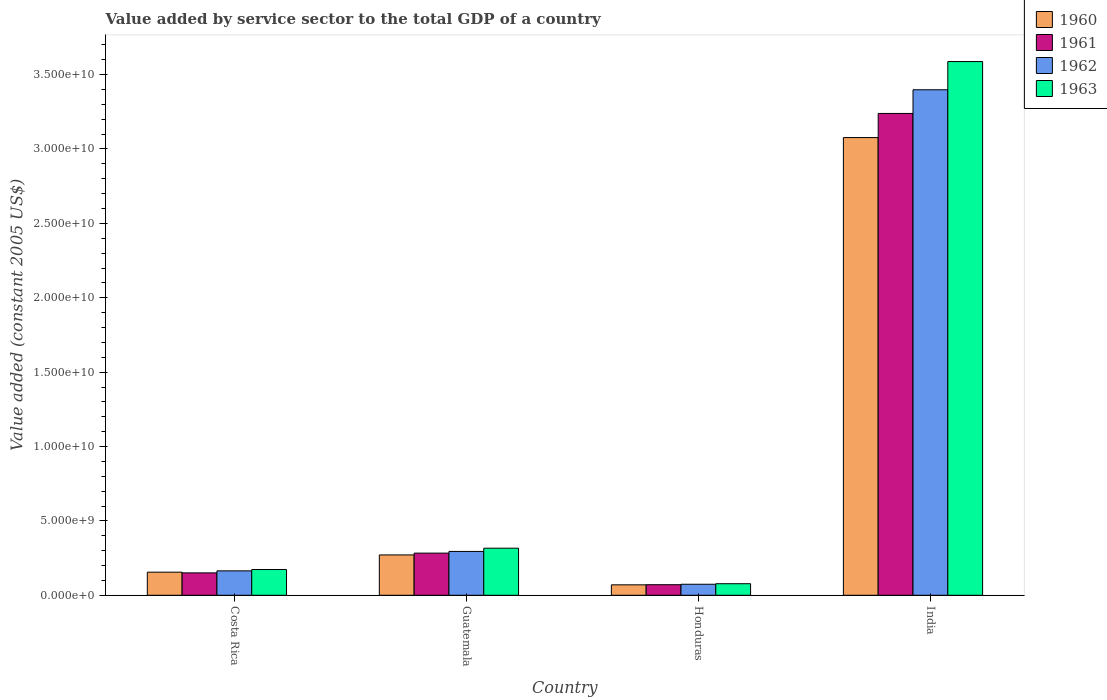How many different coloured bars are there?
Your answer should be compact. 4. Are the number of bars per tick equal to the number of legend labels?
Provide a succinct answer. Yes. What is the label of the 3rd group of bars from the left?
Offer a very short reply. Honduras. In how many cases, is the number of bars for a given country not equal to the number of legend labels?
Offer a very short reply. 0. What is the value added by service sector in 1963 in India?
Keep it short and to the point. 3.59e+1. Across all countries, what is the maximum value added by service sector in 1963?
Provide a short and direct response. 3.59e+1. Across all countries, what is the minimum value added by service sector in 1961?
Keep it short and to the point. 7.12e+08. In which country was the value added by service sector in 1961 minimum?
Offer a terse response. Honduras. What is the total value added by service sector in 1960 in the graph?
Keep it short and to the point. 3.57e+1. What is the difference between the value added by service sector in 1961 in Guatemala and that in Honduras?
Your answer should be compact. 2.12e+09. What is the difference between the value added by service sector in 1963 in Guatemala and the value added by service sector in 1962 in India?
Give a very brief answer. -3.08e+1. What is the average value added by service sector in 1960 per country?
Your answer should be compact. 8.93e+09. What is the difference between the value added by service sector of/in 1960 and value added by service sector of/in 1963 in Guatemala?
Offer a very short reply. -4.53e+08. What is the ratio of the value added by service sector in 1961 in Costa Rica to that in Honduras?
Make the answer very short. 2.12. What is the difference between the highest and the second highest value added by service sector in 1961?
Your response must be concise. 2.96e+1. What is the difference between the highest and the lowest value added by service sector in 1961?
Give a very brief answer. 3.17e+1. Is it the case that in every country, the sum of the value added by service sector in 1960 and value added by service sector in 1962 is greater than the sum of value added by service sector in 1963 and value added by service sector in 1961?
Make the answer very short. No. Are all the bars in the graph horizontal?
Keep it short and to the point. No. What is the difference between two consecutive major ticks on the Y-axis?
Keep it short and to the point. 5.00e+09. Where does the legend appear in the graph?
Your answer should be compact. Top right. What is the title of the graph?
Offer a very short reply. Value added by service sector to the total GDP of a country. Does "1970" appear as one of the legend labels in the graph?
Your response must be concise. No. What is the label or title of the X-axis?
Give a very brief answer. Country. What is the label or title of the Y-axis?
Ensure brevity in your answer.  Value added (constant 2005 US$). What is the Value added (constant 2005 US$) of 1960 in Costa Rica?
Give a very brief answer. 1.55e+09. What is the Value added (constant 2005 US$) of 1961 in Costa Rica?
Offer a terse response. 1.51e+09. What is the Value added (constant 2005 US$) of 1962 in Costa Rica?
Keep it short and to the point. 1.64e+09. What is the Value added (constant 2005 US$) in 1963 in Costa Rica?
Your answer should be very brief. 1.73e+09. What is the Value added (constant 2005 US$) in 1960 in Guatemala?
Ensure brevity in your answer.  2.71e+09. What is the Value added (constant 2005 US$) in 1961 in Guatemala?
Provide a short and direct response. 2.83e+09. What is the Value added (constant 2005 US$) of 1962 in Guatemala?
Offer a terse response. 2.95e+09. What is the Value added (constant 2005 US$) of 1963 in Guatemala?
Offer a very short reply. 3.16e+09. What is the Value added (constant 2005 US$) in 1960 in Honduras?
Provide a short and direct response. 7.01e+08. What is the Value added (constant 2005 US$) in 1961 in Honduras?
Your answer should be very brief. 7.12e+08. What is the Value added (constant 2005 US$) in 1962 in Honduras?
Your answer should be compact. 7.41e+08. What is the Value added (constant 2005 US$) in 1963 in Honduras?
Your response must be concise. 7.78e+08. What is the Value added (constant 2005 US$) of 1960 in India?
Give a very brief answer. 3.08e+1. What is the Value added (constant 2005 US$) in 1961 in India?
Your answer should be compact. 3.24e+1. What is the Value added (constant 2005 US$) in 1962 in India?
Give a very brief answer. 3.40e+1. What is the Value added (constant 2005 US$) of 1963 in India?
Ensure brevity in your answer.  3.59e+1. Across all countries, what is the maximum Value added (constant 2005 US$) in 1960?
Make the answer very short. 3.08e+1. Across all countries, what is the maximum Value added (constant 2005 US$) of 1961?
Your response must be concise. 3.24e+1. Across all countries, what is the maximum Value added (constant 2005 US$) of 1962?
Your answer should be very brief. 3.40e+1. Across all countries, what is the maximum Value added (constant 2005 US$) of 1963?
Ensure brevity in your answer.  3.59e+1. Across all countries, what is the minimum Value added (constant 2005 US$) of 1960?
Your answer should be very brief. 7.01e+08. Across all countries, what is the minimum Value added (constant 2005 US$) in 1961?
Provide a short and direct response. 7.12e+08. Across all countries, what is the minimum Value added (constant 2005 US$) of 1962?
Offer a terse response. 7.41e+08. Across all countries, what is the minimum Value added (constant 2005 US$) of 1963?
Offer a very short reply. 7.78e+08. What is the total Value added (constant 2005 US$) of 1960 in the graph?
Make the answer very short. 3.57e+1. What is the total Value added (constant 2005 US$) of 1961 in the graph?
Your answer should be compact. 3.74e+1. What is the total Value added (constant 2005 US$) in 1962 in the graph?
Make the answer very short. 3.93e+1. What is the total Value added (constant 2005 US$) of 1963 in the graph?
Keep it short and to the point. 4.16e+1. What is the difference between the Value added (constant 2005 US$) in 1960 in Costa Rica and that in Guatemala?
Your answer should be compact. -1.16e+09. What is the difference between the Value added (constant 2005 US$) in 1961 in Costa Rica and that in Guatemala?
Offer a very short reply. -1.33e+09. What is the difference between the Value added (constant 2005 US$) of 1962 in Costa Rica and that in Guatemala?
Give a very brief answer. -1.31e+09. What is the difference between the Value added (constant 2005 US$) of 1963 in Costa Rica and that in Guatemala?
Your answer should be compact. -1.43e+09. What is the difference between the Value added (constant 2005 US$) in 1960 in Costa Rica and that in Honduras?
Provide a succinct answer. 8.51e+08. What is the difference between the Value added (constant 2005 US$) of 1961 in Costa Rica and that in Honduras?
Your answer should be very brief. 7.94e+08. What is the difference between the Value added (constant 2005 US$) of 1962 in Costa Rica and that in Honduras?
Your answer should be very brief. 9.01e+08. What is the difference between the Value added (constant 2005 US$) of 1963 in Costa Rica and that in Honduras?
Make the answer very short. 9.53e+08. What is the difference between the Value added (constant 2005 US$) of 1960 in Costa Rica and that in India?
Offer a terse response. -2.92e+1. What is the difference between the Value added (constant 2005 US$) in 1961 in Costa Rica and that in India?
Your response must be concise. -3.09e+1. What is the difference between the Value added (constant 2005 US$) of 1962 in Costa Rica and that in India?
Give a very brief answer. -3.23e+1. What is the difference between the Value added (constant 2005 US$) of 1963 in Costa Rica and that in India?
Make the answer very short. -3.41e+1. What is the difference between the Value added (constant 2005 US$) in 1960 in Guatemala and that in Honduras?
Give a very brief answer. 2.01e+09. What is the difference between the Value added (constant 2005 US$) in 1961 in Guatemala and that in Honduras?
Give a very brief answer. 2.12e+09. What is the difference between the Value added (constant 2005 US$) in 1962 in Guatemala and that in Honduras?
Offer a terse response. 2.21e+09. What is the difference between the Value added (constant 2005 US$) in 1963 in Guatemala and that in Honduras?
Offer a very short reply. 2.39e+09. What is the difference between the Value added (constant 2005 US$) in 1960 in Guatemala and that in India?
Provide a short and direct response. -2.81e+1. What is the difference between the Value added (constant 2005 US$) in 1961 in Guatemala and that in India?
Provide a succinct answer. -2.96e+1. What is the difference between the Value added (constant 2005 US$) of 1962 in Guatemala and that in India?
Ensure brevity in your answer.  -3.10e+1. What is the difference between the Value added (constant 2005 US$) of 1963 in Guatemala and that in India?
Keep it short and to the point. -3.27e+1. What is the difference between the Value added (constant 2005 US$) in 1960 in Honduras and that in India?
Provide a succinct answer. -3.01e+1. What is the difference between the Value added (constant 2005 US$) of 1961 in Honduras and that in India?
Provide a succinct answer. -3.17e+1. What is the difference between the Value added (constant 2005 US$) in 1962 in Honduras and that in India?
Your answer should be compact. -3.32e+1. What is the difference between the Value added (constant 2005 US$) in 1963 in Honduras and that in India?
Your answer should be compact. -3.51e+1. What is the difference between the Value added (constant 2005 US$) of 1960 in Costa Rica and the Value added (constant 2005 US$) of 1961 in Guatemala?
Give a very brief answer. -1.28e+09. What is the difference between the Value added (constant 2005 US$) of 1960 in Costa Rica and the Value added (constant 2005 US$) of 1962 in Guatemala?
Provide a short and direct response. -1.39e+09. What is the difference between the Value added (constant 2005 US$) in 1960 in Costa Rica and the Value added (constant 2005 US$) in 1963 in Guatemala?
Your answer should be compact. -1.61e+09. What is the difference between the Value added (constant 2005 US$) in 1961 in Costa Rica and the Value added (constant 2005 US$) in 1962 in Guatemala?
Your response must be concise. -1.44e+09. What is the difference between the Value added (constant 2005 US$) in 1961 in Costa Rica and the Value added (constant 2005 US$) in 1963 in Guatemala?
Ensure brevity in your answer.  -1.66e+09. What is the difference between the Value added (constant 2005 US$) of 1962 in Costa Rica and the Value added (constant 2005 US$) of 1963 in Guatemala?
Provide a succinct answer. -1.52e+09. What is the difference between the Value added (constant 2005 US$) of 1960 in Costa Rica and the Value added (constant 2005 US$) of 1961 in Honduras?
Your answer should be very brief. 8.41e+08. What is the difference between the Value added (constant 2005 US$) of 1960 in Costa Rica and the Value added (constant 2005 US$) of 1962 in Honduras?
Provide a short and direct response. 8.12e+08. What is the difference between the Value added (constant 2005 US$) in 1960 in Costa Rica and the Value added (constant 2005 US$) in 1963 in Honduras?
Make the answer very short. 7.75e+08. What is the difference between the Value added (constant 2005 US$) in 1961 in Costa Rica and the Value added (constant 2005 US$) in 1962 in Honduras?
Your answer should be compact. 7.65e+08. What is the difference between the Value added (constant 2005 US$) of 1961 in Costa Rica and the Value added (constant 2005 US$) of 1963 in Honduras?
Offer a very short reply. 7.28e+08. What is the difference between the Value added (constant 2005 US$) in 1962 in Costa Rica and the Value added (constant 2005 US$) in 1963 in Honduras?
Make the answer very short. 8.63e+08. What is the difference between the Value added (constant 2005 US$) in 1960 in Costa Rica and the Value added (constant 2005 US$) in 1961 in India?
Your answer should be compact. -3.08e+1. What is the difference between the Value added (constant 2005 US$) in 1960 in Costa Rica and the Value added (constant 2005 US$) in 1962 in India?
Your answer should be compact. -3.24e+1. What is the difference between the Value added (constant 2005 US$) in 1960 in Costa Rica and the Value added (constant 2005 US$) in 1963 in India?
Give a very brief answer. -3.43e+1. What is the difference between the Value added (constant 2005 US$) of 1961 in Costa Rica and the Value added (constant 2005 US$) of 1962 in India?
Offer a terse response. -3.25e+1. What is the difference between the Value added (constant 2005 US$) in 1961 in Costa Rica and the Value added (constant 2005 US$) in 1963 in India?
Keep it short and to the point. -3.44e+1. What is the difference between the Value added (constant 2005 US$) of 1962 in Costa Rica and the Value added (constant 2005 US$) of 1963 in India?
Give a very brief answer. -3.42e+1. What is the difference between the Value added (constant 2005 US$) in 1960 in Guatemala and the Value added (constant 2005 US$) in 1961 in Honduras?
Provide a succinct answer. 2.00e+09. What is the difference between the Value added (constant 2005 US$) in 1960 in Guatemala and the Value added (constant 2005 US$) in 1962 in Honduras?
Your answer should be very brief. 1.97e+09. What is the difference between the Value added (constant 2005 US$) in 1960 in Guatemala and the Value added (constant 2005 US$) in 1963 in Honduras?
Your answer should be very brief. 1.93e+09. What is the difference between the Value added (constant 2005 US$) in 1961 in Guatemala and the Value added (constant 2005 US$) in 1962 in Honduras?
Your answer should be compact. 2.09e+09. What is the difference between the Value added (constant 2005 US$) of 1961 in Guatemala and the Value added (constant 2005 US$) of 1963 in Honduras?
Your answer should be very brief. 2.06e+09. What is the difference between the Value added (constant 2005 US$) of 1962 in Guatemala and the Value added (constant 2005 US$) of 1963 in Honduras?
Offer a terse response. 2.17e+09. What is the difference between the Value added (constant 2005 US$) of 1960 in Guatemala and the Value added (constant 2005 US$) of 1961 in India?
Offer a very short reply. -2.97e+1. What is the difference between the Value added (constant 2005 US$) of 1960 in Guatemala and the Value added (constant 2005 US$) of 1962 in India?
Keep it short and to the point. -3.13e+1. What is the difference between the Value added (constant 2005 US$) of 1960 in Guatemala and the Value added (constant 2005 US$) of 1963 in India?
Offer a terse response. -3.32e+1. What is the difference between the Value added (constant 2005 US$) in 1961 in Guatemala and the Value added (constant 2005 US$) in 1962 in India?
Your answer should be very brief. -3.11e+1. What is the difference between the Value added (constant 2005 US$) of 1961 in Guatemala and the Value added (constant 2005 US$) of 1963 in India?
Provide a short and direct response. -3.30e+1. What is the difference between the Value added (constant 2005 US$) of 1962 in Guatemala and the Value added (constant 2005 US$) of 1963 in India?
Your answer should be compact. -3.29e+1. What is the difference between the Value added (constant 2005 US$) in 1960 in Honduras and the Value added (constant 2005 US$) in 1961 in India?
Keep it short and to the point. -3.17e+1. What is the difference between the Value added (constant 2005 US$) in 1960 in Honduras and the Value added (constant 2005 US$) in 1962 in India?
Your answer should be very brief. -3.33e+1. What is the difference between the Value added (constant 2005 US$) of 1960 in Honduras and the Value added (constant 2005 US$) of 1963 in India?
Provide a succinct answer. -3.52e+1. What is the difference between the Value added (constant 2005 US$) of 1961 in Honduras and the Value added (constant 2005 US$) of 1962 in India?
Your answer should be very brief. -3.33e+1. What is the difference between the Value added (constant 2005 US$) in 1961 in Honduras and the Value added (constant 2005 US$) in 1963 in India?
Give a very brief answer. -3.52e+1. What is the difference between the Value added (constant 2005 US$) in 1962 in Honduras and the Value added (constant 2005 US$) in 1963 in India?
Ensure brevity in your answer.  -3.51e+1. What is the average Value added (constant 2005 US$) in 1960 per country?
Offer a very short reply. 8.93e+09. What is the average Value added (constant 2005 US$) in 1961 per country?
Your answer should be compact. 9.36e+09. What is the average Value added (constant 2005 US$) in 1962 per country?
Provide a short and direct response. 9.83e+09. What is the average Value added (constant 2005 US$) in 1963 per country?
Provide a short and direct response. 1.04e+1. What is the difference between the Value added (constant 2005 US$) in 1960 and Value added (constant 2005 US$) in 1961 in Costa Rica?
Offer a very short reply. 4.72e+07. What is the difference between the Value added (constant 2005 US$) of 1960 and Value added (constant 2005 US$) of 1962 in Costa Rica?
Provide a succinct answer. -8.87e+07. What is the difference between the Value added (constant 2005 US$) of 1960 and Value added (constant 2005 US$) of 1963 in Costa Rica?
Offer a very short reply. -1.78e+08. What is the difference between the Value added (constant 2005 US$) in 1961 and Value added (constant 2005 US$) in 1962 in Costa Rica?
Offer a terse response. -1.36e+08. What is the difference between the Value added (constant 2005 US$) of 1961 and Value added (constant 2005 US$) of 1963 in Costa Rica?
Keep it short and to the point. -2.25e+08. What is the difference between the Value added (constant 2005 US$) of 1962 and Value added (constant 2005 US$) of 1963 in Costa Rica?
Provide a short and direct response. -8.94e+07. What is the difference between the Value added (constant 2005 US$) in 1960 and Value added (constant 2005 US$) in 1961 in Guatemala?
Make the answer very short. -1.22e+08. What is the difference between the Value added (constant 2005 US$) in 1960 and Value added (constant 2005 US$) in 1962 in Guatemala?
Provide a succinct answer. -2.35e+08. What is the difference between the Value added (constant 2005 US$) in 1960 and Value added (constant 2005 US$) in 1963 in Guatemala?
Make the answer very short. -4.53e+08. What is the difference between the Value added (constant 2005 US$) in 1961 and Value added (constant 2005 US$) in 1962 in Guatemala?
Your answer should be very brief. -1.14e+08. What is the difference between the Value added (constant 2005 US$) in 1961 and Value added (constant 2005 US$) in 1963 in Guatemala?
Offer a terse response. -3.31e+08. What is the difference between the Value added (constant 2005 US$) in 1962 and Value added (constant 2005 US$) in 1963 in Guatemala?
Make the answer very short. -2.17e+08. What is the difference between the Value added (constant 2005 US$) of 1960 and Value added (constant 2005 US$) of 1961 in Honduras?
Provide a short and direct response. -1.04e+07. What is the difference between the Value added (constant 2005 US$) of 1960 and Value added (constant 2005 US$) of 1962 in Honduras?
Provide a succinct answer. -3.93e+07. What is the difference between the Value added (constant 2005 US$) of 1960 and Value added (constant 2005 US$) of 1963 in Honduras?
Ensure brevity in your answer.  -7.65e+07. What is the difference between the Value added (constant 2005 US$) of 1961 and Value added (constant 2005 US$) of 1962 in Honduras?
Give a very brief answer. -2.89e+07. What is the difference between the Value added (constant 2005 US$) in 1961 and Value added (constant 2005 US$) in 1963 in Honduras?
Make the answer very short. -6.62e+07. What is the difference between the Value added (constant 2005 US$) of 1962 and Value added (constant 2005 US$) of 1963 in Honduras?
Make the answer very short. -3.72e+07. What is the difference between the Value added (constant 2005 US$) of 1960 and Value added (constant 2005 US$) of 1961 in India?
Make the answer very short. -1.62e+09. What is the difference between the Value added (constant 2005 US$) of 1960 and Value added (constant 2005 US$) of 1962 in India?
Ensure brevity in your answer.  -3.21e+09. What is the difference between the Value added (constant 2005 US$) of 1960 and Value added (constant 2005 US$) of 1963 in India?
Your answer should be very brief. -5.11e+09. What is the difference between the Value added (constant 2005 US$) of 1961 and Value added (constant 2005 US$) of 1962 in India?
Ensure brevity in your answer.  -1.59e+09. What is the difference between the Value added (constant 2005 US$) of 1961 and Value added (constant 2005 US$) of 1963 in India?
Your answer should be very brief. -3.49e+09. What is the difference between the Value added (constant 2005 US$) in 1962 and Value added (constant 2005 US$) in 1963 in India?
Provide a short and direct response. -1.90e+09. What is the ratio of the Value added (constant 2005 US$) in 1960 in Costa Rica to that in Guatemala?
Offer a very short reply. 0.57. What is the ratio of the Value added (constant 2005 US$) of 1961 in Costa Rica to that in Guatemala?
Ensure brevity in your answer.  0.53. What is the ratio of the Value added (constant 2005 US$) in 1962 in Costa Rica to that in Guatemala?
Offer a very short reply. 0.56. What is the ratio of the Value added (constant 2005 US$) in 1963 in Costa Rica to that in Guatemala?
Your answer should be very brief. 0.55. What is the ratio of the Value added (constant 2005 US$) in 1960 in Costa Rica to that in Honduras?
Offer a very short reply. 2.21. What is the ratio of the Value added (constant 2005 US$) of 1961 in Costa Rica to that in Honduras?
Your answer should be very brief. 2.12. What is the ratio of the Value added (constant 2005 US$) of 1962 in Costa Rica to that in Honduras?
Your answer should be compact. 2.22. What is the ratio of the Value added (constant 2005 US$) in 1963 in Costa Rica to that in Honduras?
Make the answer very short. 2.23. What is the ratio of the Value added (constant 2005 US$) of 1960 in Costa Rica to that in India?
Your answer should be very brief. 0.05. What is the ratio of the Value added (constant 2005 US$) in 1961 in Costa Rica to that in India?
Make the answer very short. 0.05. What is the ratio of the Value added (constant 2005 US$) in 1962 in Costa Rica to that in India?
Your answer should be very brief. 0.05. What is the ratio of the Value added (constant 2005 US$) in 1963 in Costa Rica to that in India?
Keep it short and to the point. 0.05. What is the ratio of the Value added (constant 2005 US$) of 1960 in Guatemala to that in Honduras?
Your answer should be compact. 3.87. What is the ratio of the Value added (constant 2005 US$) of 1961 in Guatemala to that in Honduras?
Offer a very short reply. 3.98. What is the ratio of the Value added (constant 2005 US$) of 1962 in Guatemala to that in Honduras?
Give a very brief answer. 3.98. What is the ratio of the Value added (constant 2005 US$) in 1963 in Guatemala to that in Honduras?
Keep it short and to the point. 4.07. What is the ratio of the Value added (constant 2005 US$) of 1960 in Guatemala to that in India?
Offer a terse response. 0.09. What is the ratio of the Value added (constant 2005 US$) in 1961 in Guatemala to that in India?
Give a very brief answer. 0.09. What is the ratio of the Value added (constant 2005 US$) of 1962 in Guatemala to that in India?
Make the answer very short. 0.09. What is the ratio of the Value added (constant 2005 US$) in 1963 in Guatemala to that in India?
Ensure brevity in your answer.  0.09. What is the ratio of the Value added (constant 2005 US$) in 1960 in Honduras to that in India?
Your response must be concise. 0.02. What is the ratio of the Value added (constant 2005 US$) in 1961 in Honduras to that in India?
Keep it short and to the point. 0.02. What is the ratio of the Value added (constant 2005 US$) in 1962 in Honduras to that in India?
Your response must be concise. 0.02. What is the ratio of the Value added (constant 2005 US$) of 1963 in Honduras to that in India?
Your answer should be very brief. 0.02. What is the difference between the highest and the second highest Value added (constant 2005 US$) of 1960?
Provide a succinct answer. 2.81e+1. What is the difference between the highest and the second highest Value added (constant 2005 US$) of 1961?
Your answer should be very brief. 2.96e+1. What is the difference between the highest and the second highest Value added (constant 2005 US$) of 1962?
Give a very brief answer. 3.10e+1. What is the difference between the highest and the second highest Value added (constant 2005 US$) of 1963?
Your answer should be compact. 3.27e+1. What is the difference between the highest and the lowest Value added (constant 2005 US$) of 1960?
Offer a very short reply. 3.01e+1. What is the difference between the highest and the lowest Value added (constant 2005 US$) of 1961?
Your response must be concise. 3.17e+1. What is the difference between the highest and the lowest Value added (constant 2005 US$) of 1962?
Offer a terse response. 3.32e+1. What is the difference between the highest and the lowest Value added (constant 2005 US$) of 1963?
Offer a very short reply. 3.51e+1. 